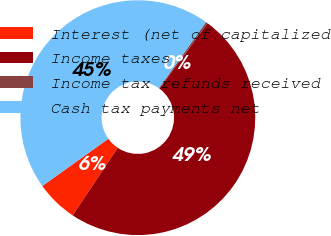<chart> <loc_0><loc_0><loc_500><loc_500><pie_chart><fcel>Interest (net of capitalized<fcel>Income taxes<fcel>Income tax refunds received<fcel>Cash tax payments net<nl><fcel>5.76%<fcel>49.22%<fcel>0.27%<fcel>44.75%<nl></chart> 